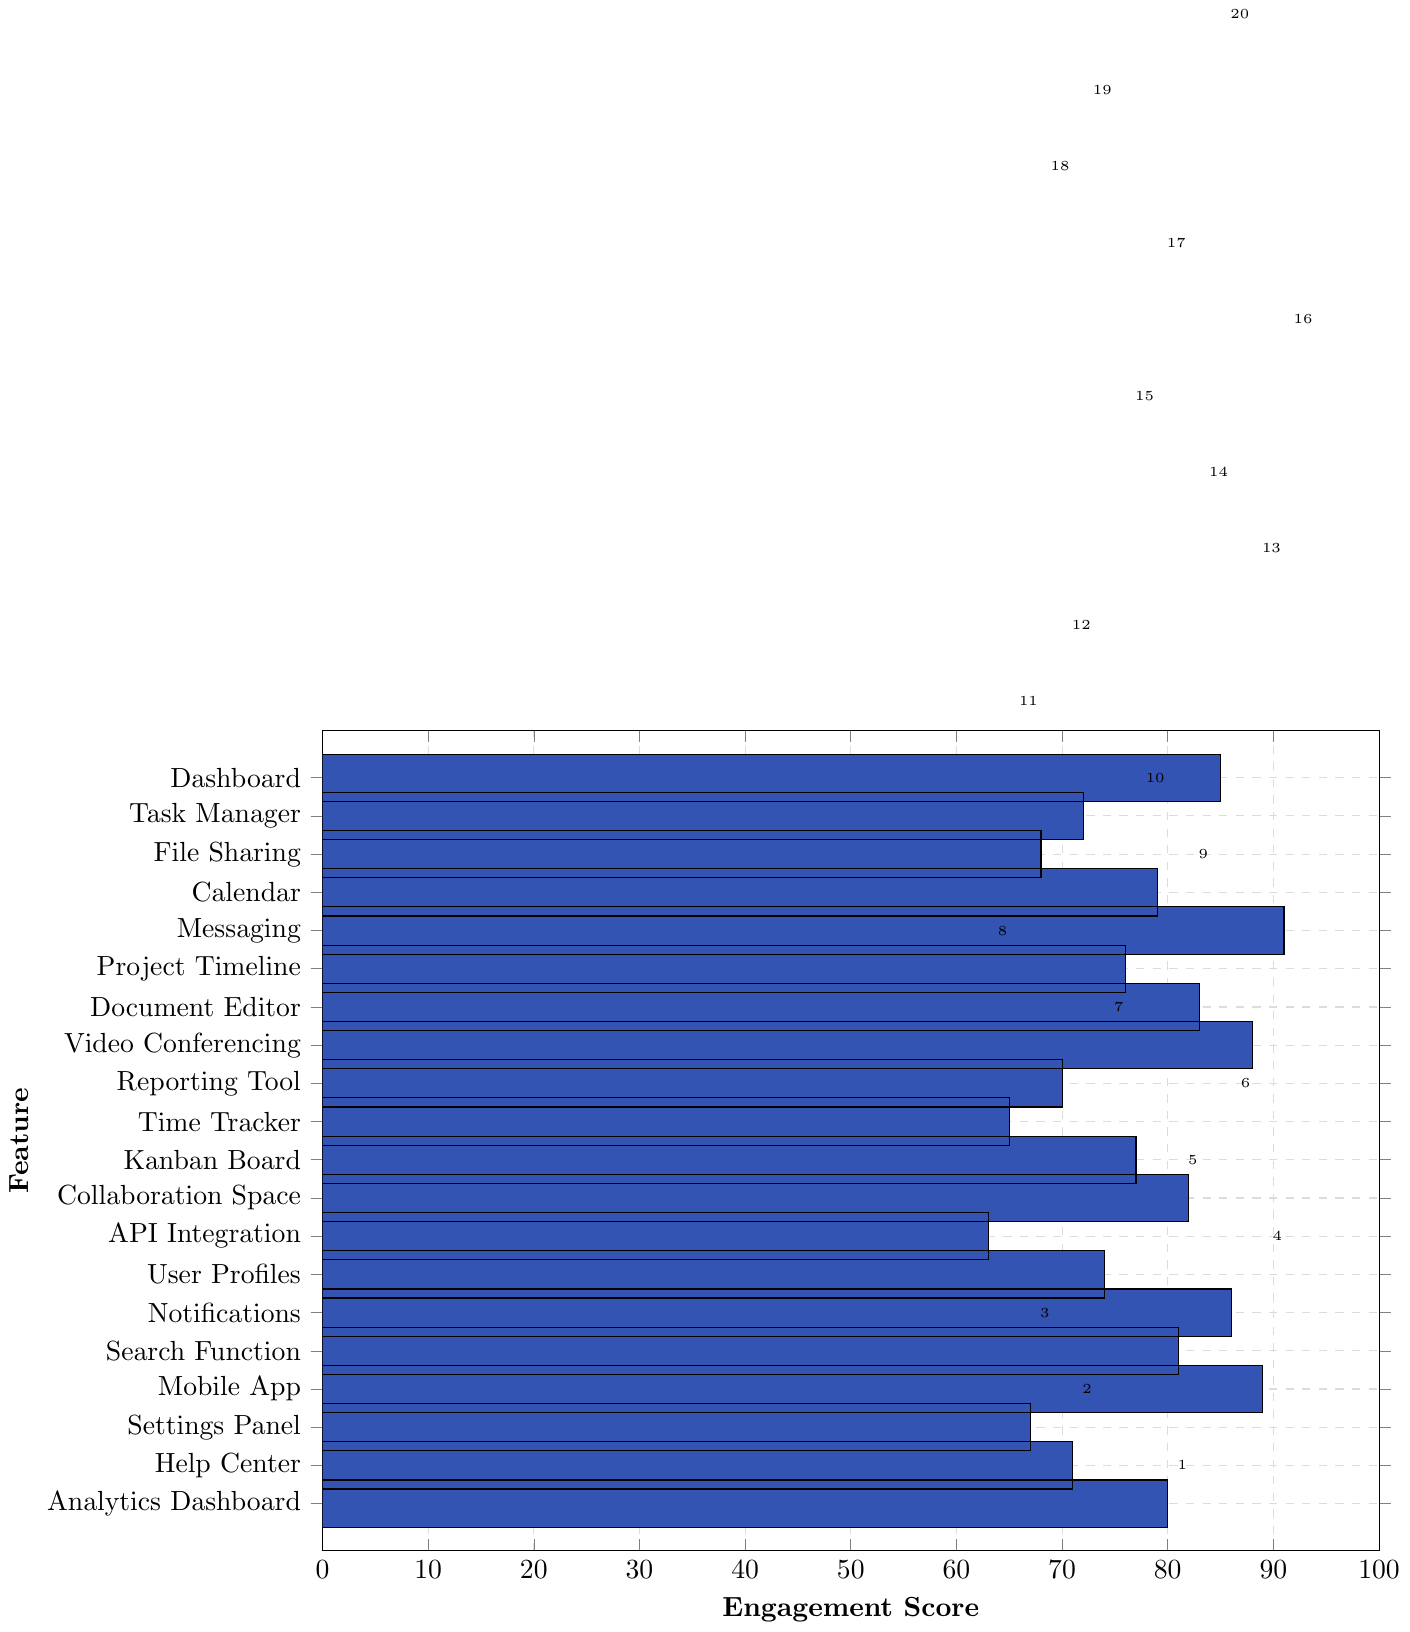Which feature has the highest engagement score? By visually inspecting the lengths of the bars, the Messaging feature has the longest bar, indicating the highest engagement score.
Answer: Messaging What is the difference in engagement score between the Task Manager and the File Sharing features? The Task Manager has an engagement score of 72, while File Sharing has a score of 68. The difference can be calculated as 72 - 68.
Answer: 4 How many features have an engagement score greater than 80? By scanning the bars, the features with engagement scores greater than 80 are Messaging, Video Conferencing, Mobile App, Notifications, Dashboard, Document Editor, and Search Function. Counting these results in 7 features.
Answer: 7 Which features have an engagement score equal to or below 70? By examining the chart, the features with scores equal to or below 70 are Help Center (71), Reporting Tool (70), Time Tracker (65), API Integration (63), and Settings Panel (67).
Answer: 5 What is the average engagement score of the top 3 features? The top 3 features are Messaging (91), Mobile App (89), and Video Conferencing (88). To find the average: (91 + 89 + 88) / 3 = 89.33.
Answer: 89.33 If the engagement score of the Collaboration Space were to increase by 10 points, what would its new score be? The current engagement score of Collaboration Space is 82. Adding 10 points results in 82 + 10 = 92.
Answer: 92 Between Calendar and Project Timeline, which feature has a higher engagement score and by how much? The engagement score for Calendar is 79 and for Project Timeline is 76. The Calendar feature is higher by 79 - 76 = 3 points.
Answer: Calendar by 3 What is the median engagement score of all features? To find the median, list all engagement scores in numerical order and find the middle value. Ordered scores: 63, 65, 67, 68, 70, 71, 72, 74, 76, 77, 79, 80, 81, 82, 83, 85, 86, 88, 89, 91. The middle values are 77 and 79. The median is (77 + 79)/2.
Answer: 78 Which feature ranks fifth in terms of engagement score? Sorting features by their scores, the fifth highest score is Search Function with an engagement score of 81.
Answer: Search Function 